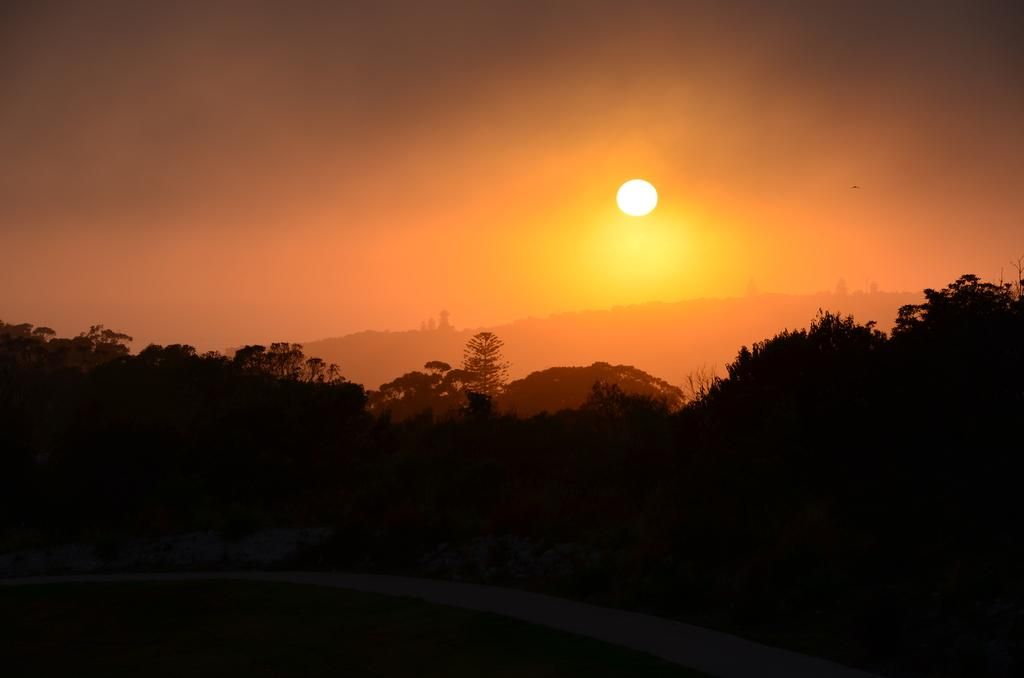What is the main feature of the image? There is a beautiful sunrise in the image. What type of natural elements can be seen in the image? There are trees in the image. What is visible in the background of the image? There is a mountain in the background of the image. How many quarters are visible in the image? There are no quarters present in the image. Does the existence of the sunrise in the image prove the existence of extraterrestrial life? The presence of a sunrise in the image does not prove the existence of extraterrestrial life, as it is a natural phenomenon on Earth. Is there a kettle boiling water in the image? There is no kettle present in the image. 